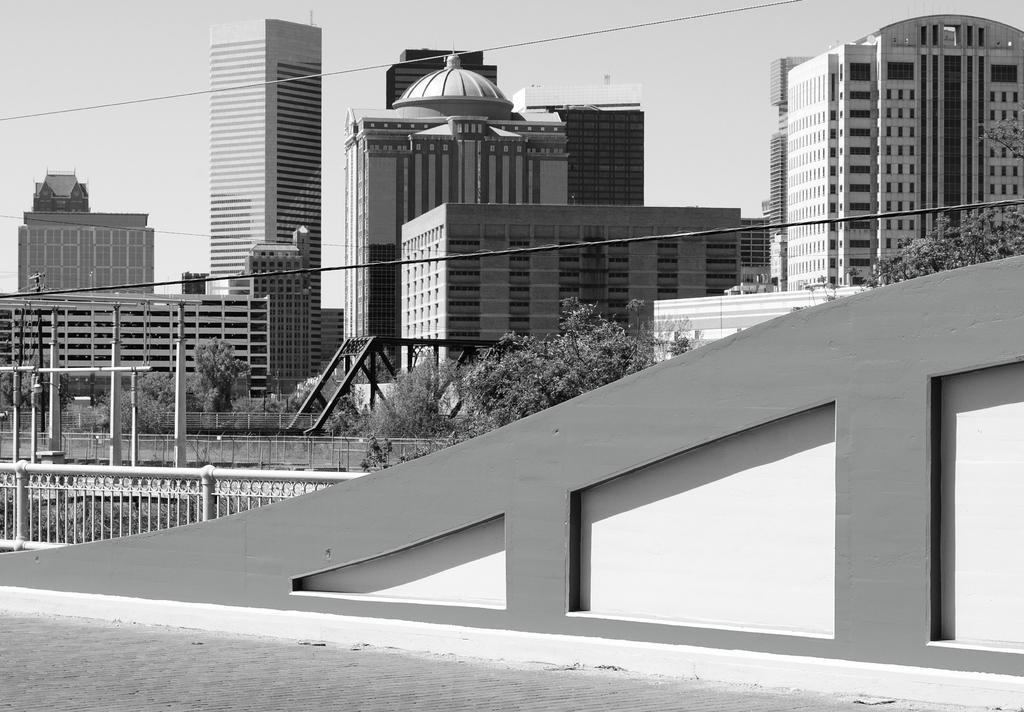Please provide a concise description of this image. This image is a black and white image. This image is taken outdoors. At the top of the image there is the sky. At the bottom of the image there is a floor. In the middle of the image there are many buildings. There are a few trees and plants. There are many iron bars. There is a railing. There is a wall and there is a fence. 